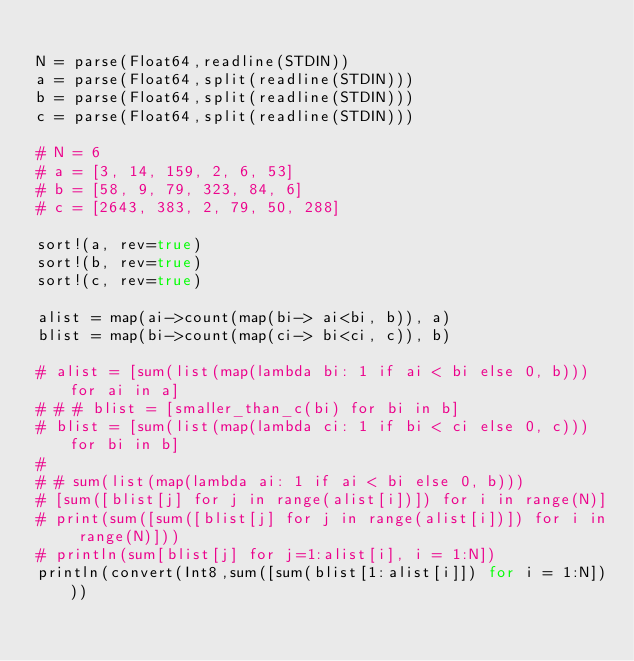Convert code to text. <code><loc_0><loc_0><loc_500><loc_500><_Julia_>
N = parse(Float64,readline(STDIN))
a = parse(Float64,split(readline(STDIN)))
b = parse(Float64,split(readline(STDIN)))
c = parse(Float64,split(readline(STDIN)))

# N = 6
# a = [3, 14, 159, 2, 6, 53]
# b = [58, 9, 79, 323, 84, 6]
# c = [2643, 383, 2, 79, 50, 288]

sort!(a, rev=true)
sort!(b, rev=true)
sort!(c, rev=true)

alist = map(ai->count(map(bi-> ai<bi, b)), a)
blist = map(bi->count(map(ci-> bi<ci, c)), b)

# alist = [sum(list(map(lambda bi: 1 if ai < bi else 0, b))) for ai in a]
# # # blist = [smaller_than_c(bi) for bi in b]
# blist = [sum(list(map(lambda ci: 1 if bi < ci else 0, c))) for bi in b]
#
# # sum(list(map(lambda ai: 1 if ai < bi else 0, b)))
# [sum([blist[j] for j in range(alist[i])]) for i in range(N)]
# print(sum([sum([blist[j] for j in range(alist[i])]) for i in range(N)]))
# println(sum[blist[j] for j=1:alist[i], i = 1:N])
println(convert(Int8,sum([sum(blist[1:alist[i]]) for i = 1:N])))
</code> 